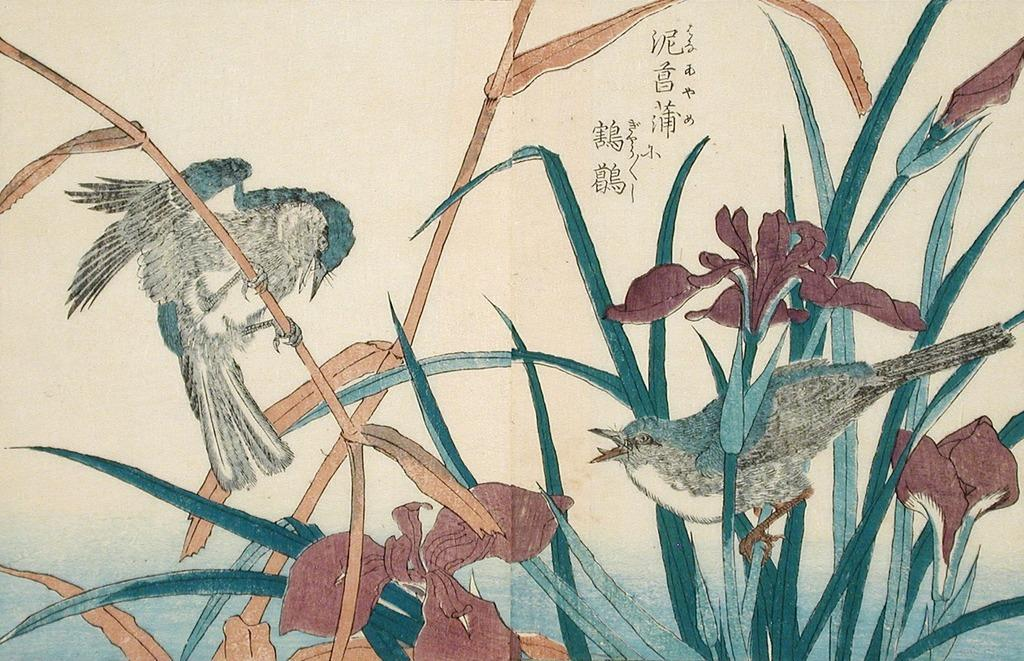What is depicted on the paper in the image? There is a drawing on a paper in the image. What type of animals can be seen in the image? There are two birds on the plants in the image. What color are the flowers in the image? There are red color flowers in the image. Can you see the smile on the fish in the image? There is no fish present in the image, so it is not possible to see a smile on a fish. 